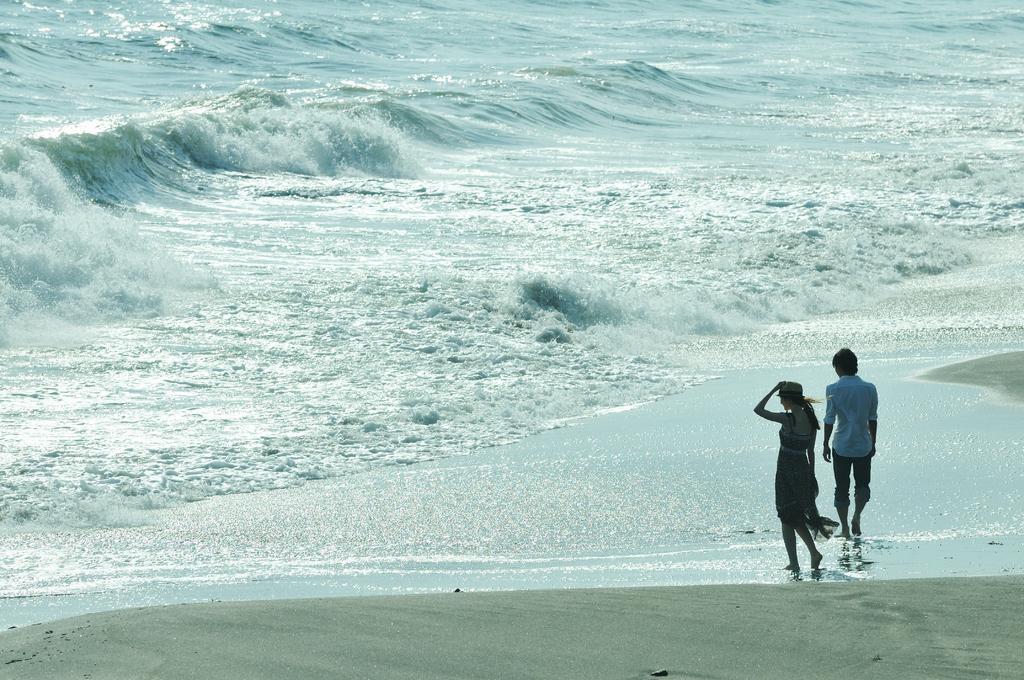Describe this image in one or two sentences. In this picture I can observe two members walking in the beach on the right side. In the background there is an ocean. 